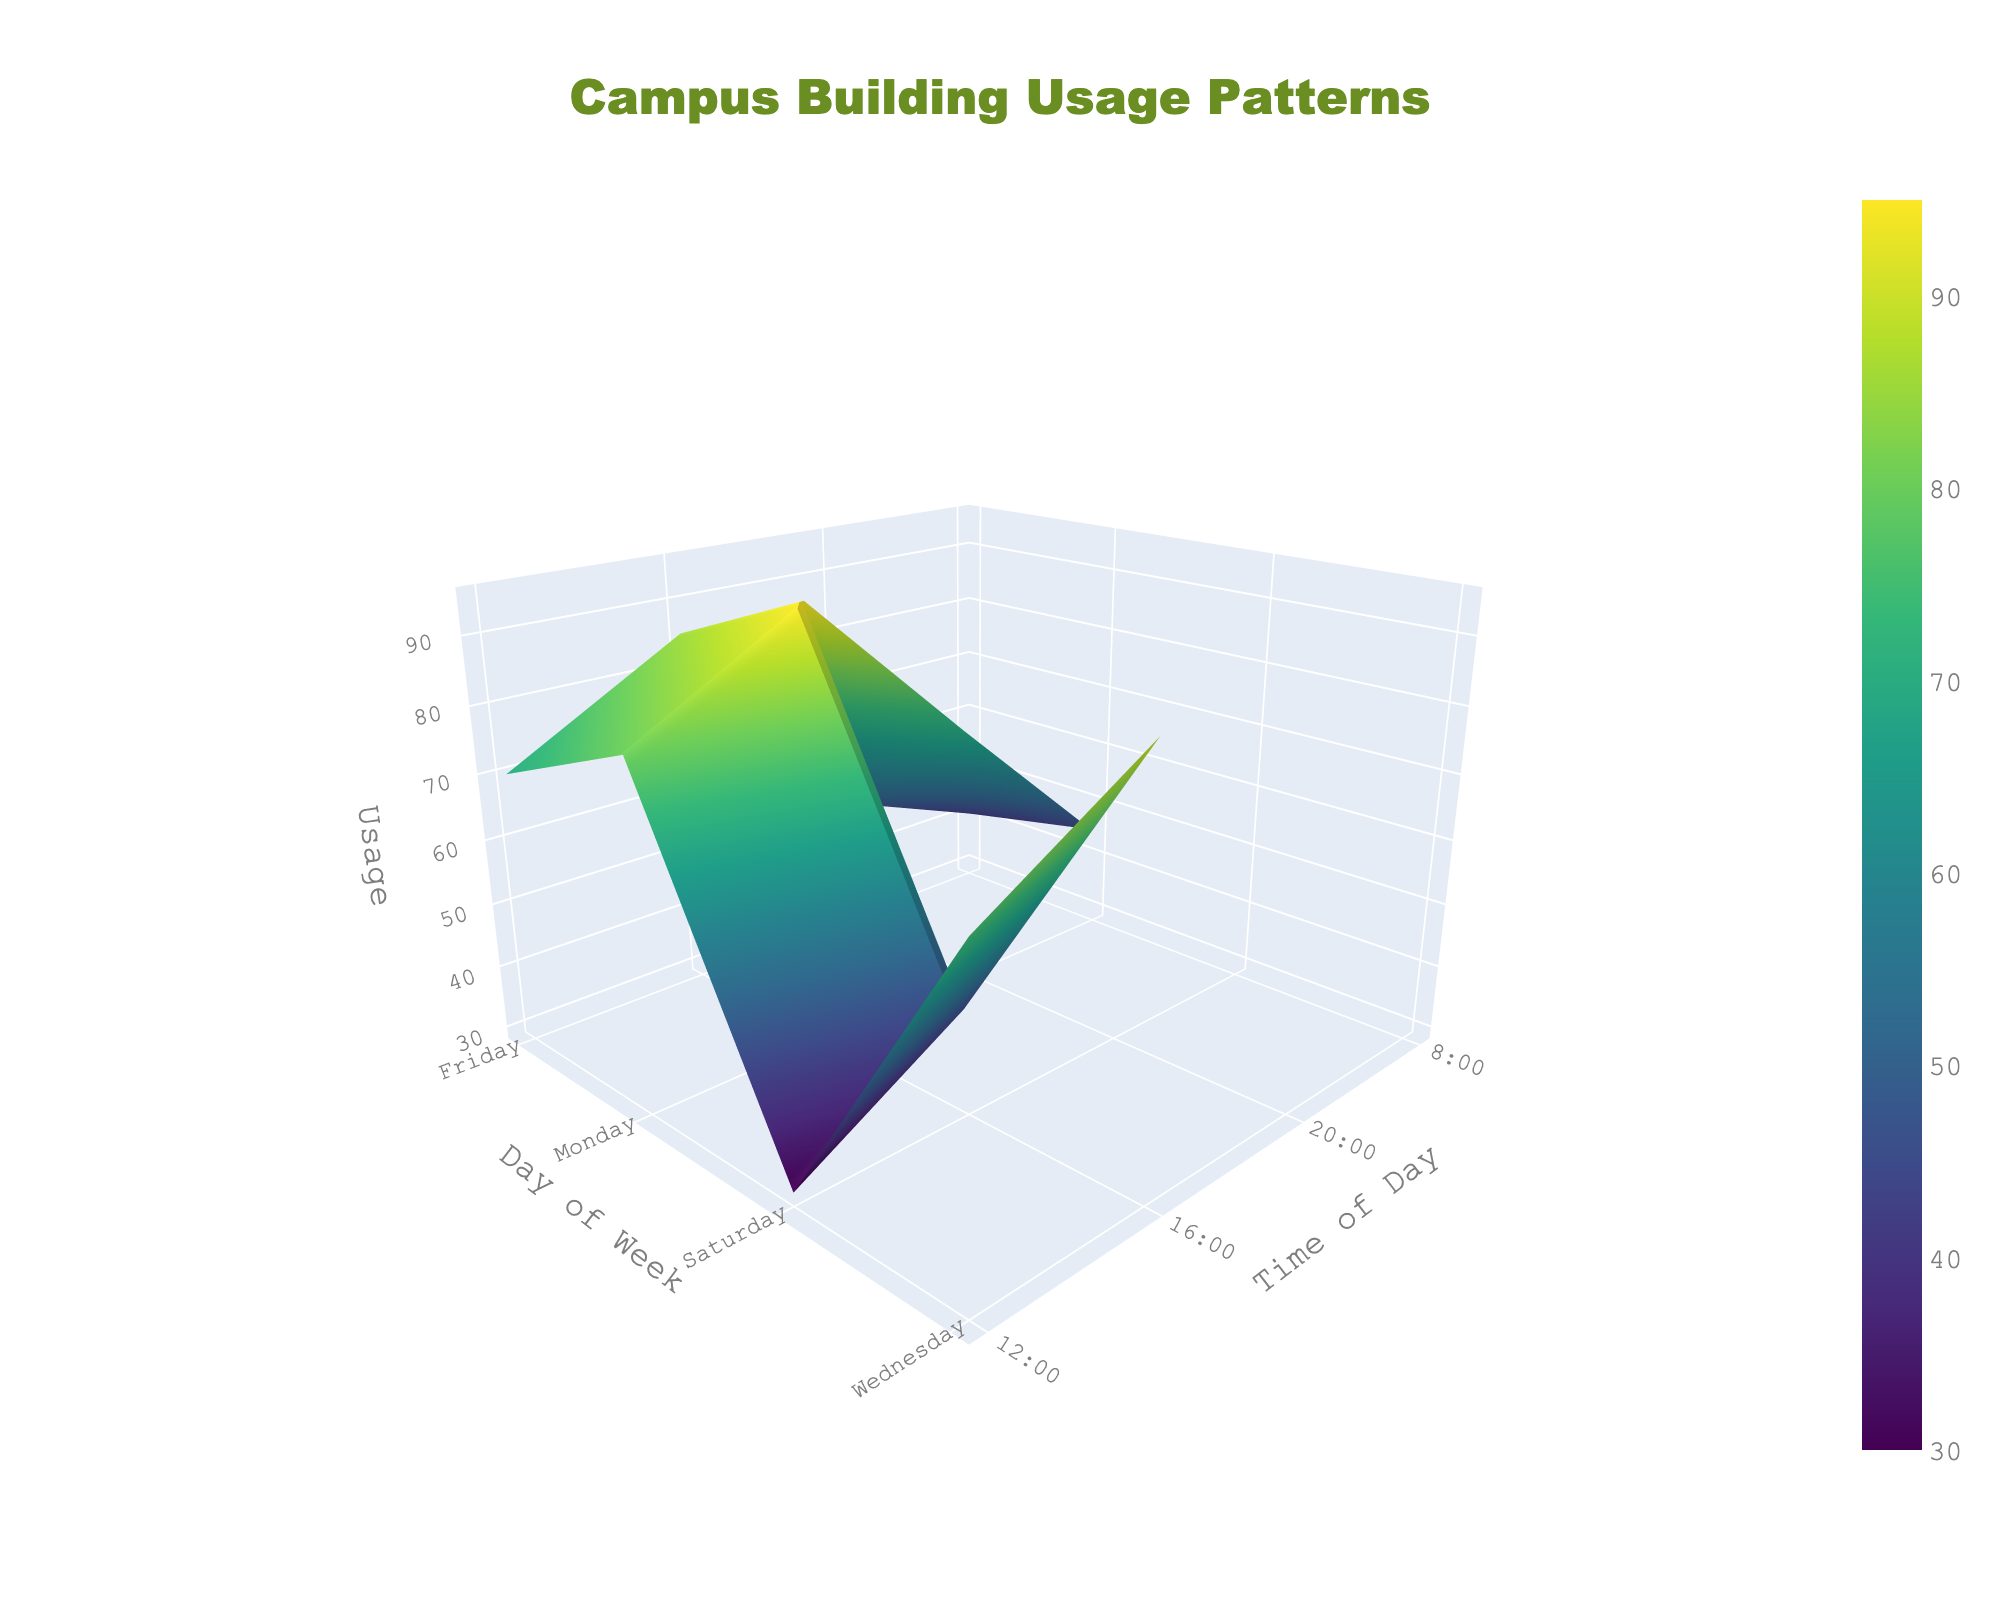What is the title of the 3D surface plot? The title appears on the top center of the figure and describes the content of the plot. The title is "Campus Building Usage Patterns".
Answer: Campus Building Usage Patterns Which day of the week shows the peak usage in the Library at 12:00? By analyzing the 3D surface plot, you can identify peaks by looking at the highest points. The highest usage at 12:00 in the Library is on Monday.
Answer: Monday What is the range of usage values in the Student Union on Fridays? To find the range, we need to identify the minimum and maximum usage values for the Student Union on Fridays. According to the plot, the usage ranges between 25 and 70.
Answer: 25 to 70 How does the usage pattern of the Library differ between Wednesday and Friday at 16:00? Compare the usage values at 16:00 for both days. On Wednesday at 16:00, the Library usage is 90, whereas on Friday at 16:00, it is 85.
Answer: Wednesday has higher usage Which time slot shows the highest student union usage on Monday? Focus on the time slots on Monday and find the highest point for the Student Union. The figure highlights 12:00 as having the highest usage.
Answer: 12:00 What is the average Library usage on Wednesday? Aggregate the usage values for all time slots on Wednesday and then divide by the number of data points: (50 + 75 + 90 + 65) / 4 = 70.
Answer: 70 What are the typical usage trends for the Library on Saturdays? By examining the data on Saturdays, the trends show that the Library usage is lower on weekends with values of 30 at 12:00 and 45 at 16:00.
Answer: Lower usage If we sum up the Student Union usage at 20:00 across all days, what would be the total? Add the values for 20:00 on all days for the Student Union: 40 (Monday) + 45 (Wednesday) + 70 (Friday) = 155.
Answer: 155 Between Monday and Friday, which day shows higher Student Union usage at 12:00? Compare the Student Union usage values at 12:00 for Monday (85) and Friday (80). Monday shows slightly higher usage.
Answer: Monday Which time of the day is least busy in the Library on Fridays? Identify the time with the lowest usage value in the Library on Fridays. The plot shows that 8:00 has the lowest usage, which is 40.
Answer: 8:00 